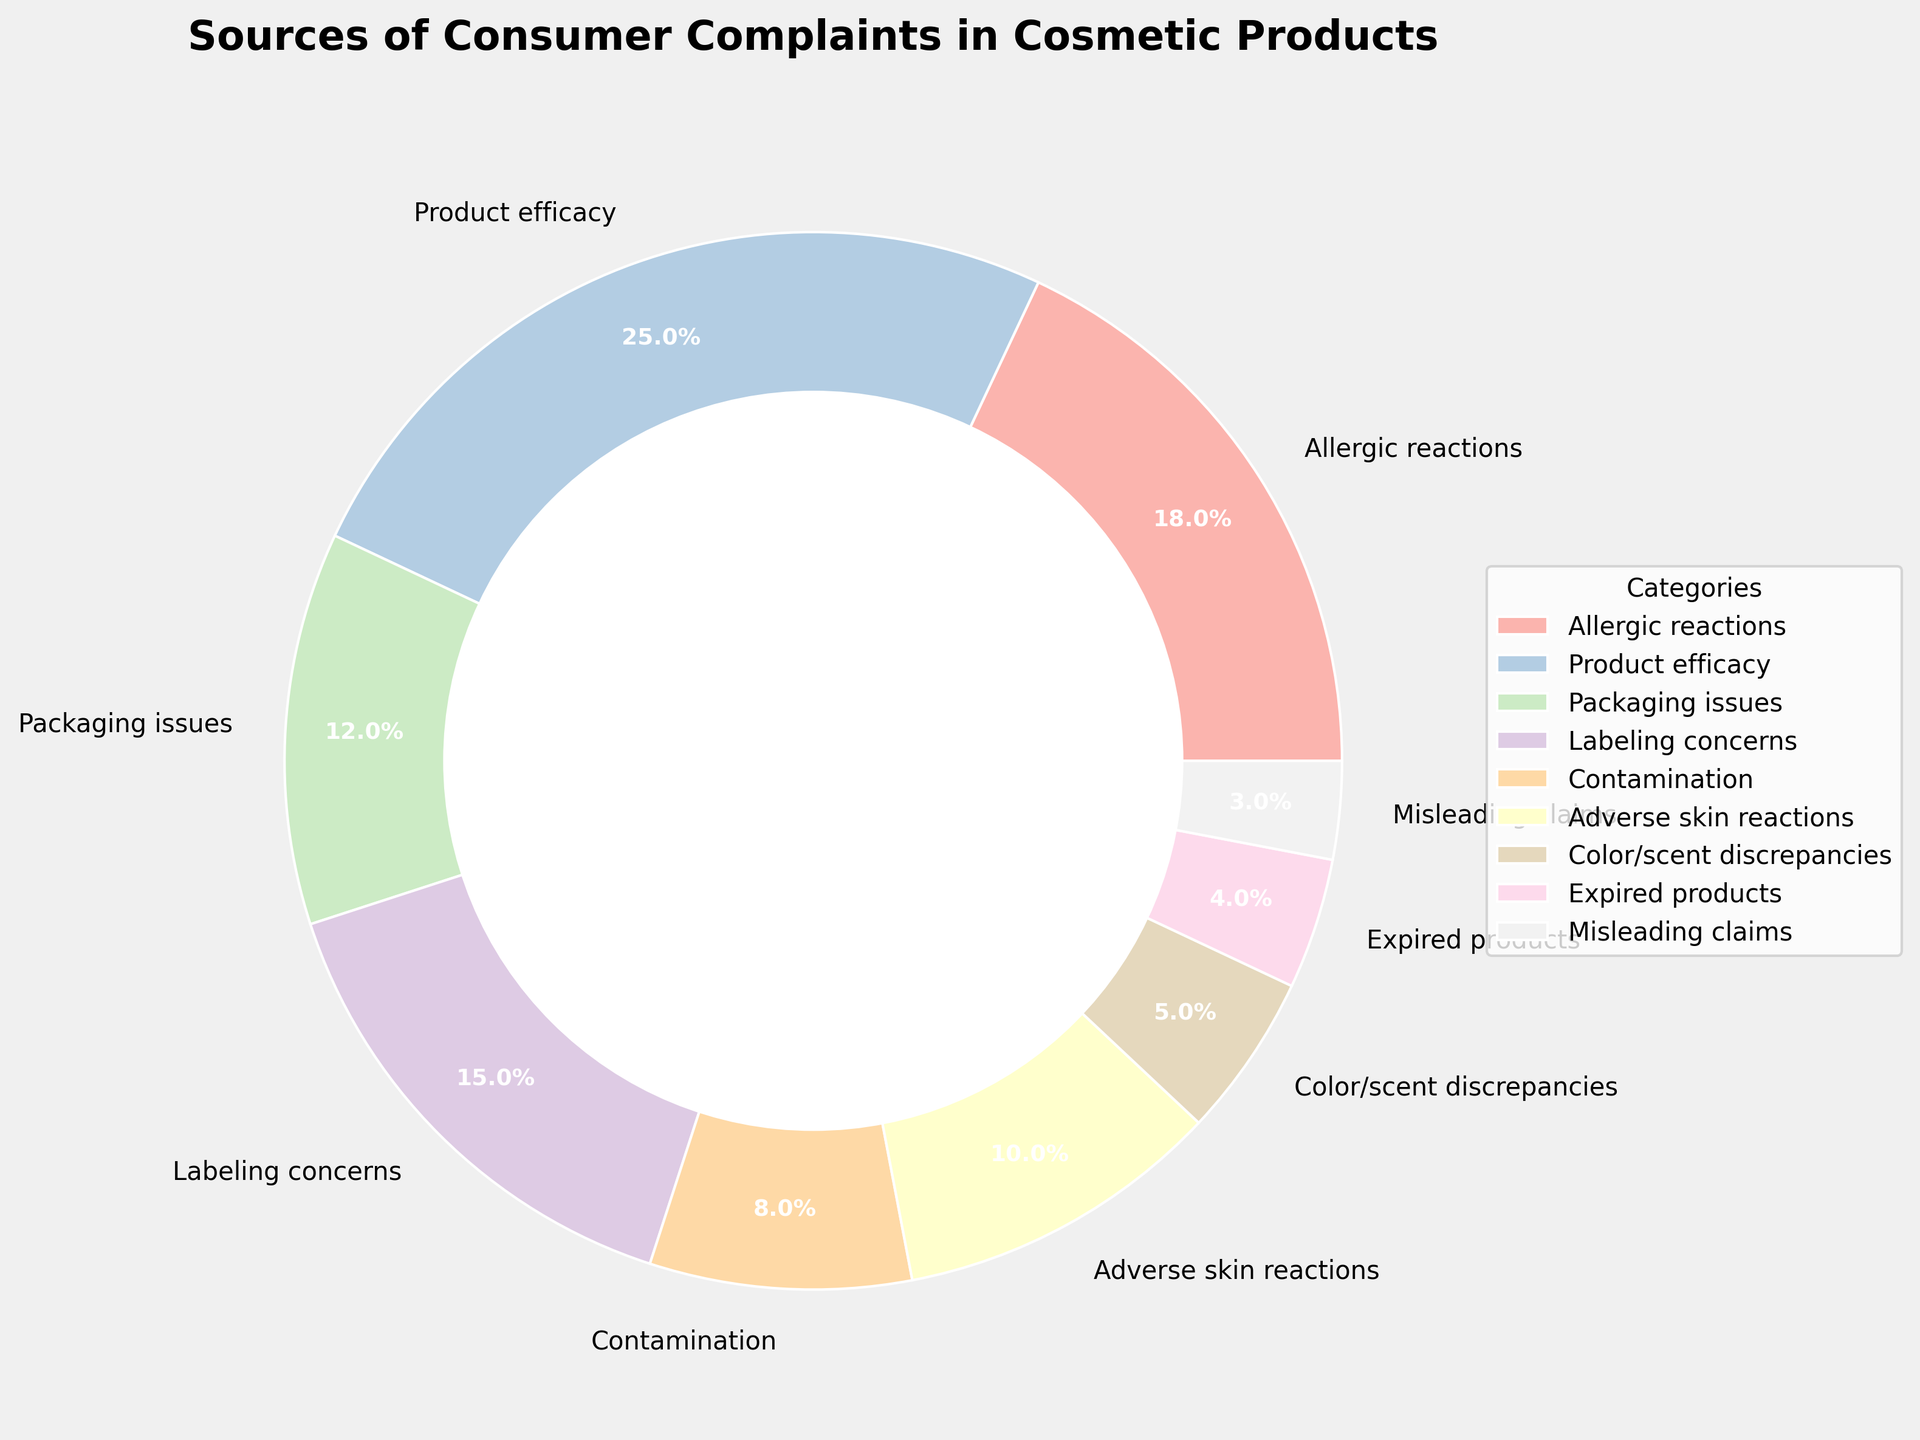What percentage of complaints are related to allergic reactions? The pie chart shows that 18% of consumer complaints are related to allergic reactions.
Answer: 18% Which category has the highest percentage of consumer complaints? By looking at the pie chart, the "Product efficacy" category has the highest percentage of complaints, which is 25%.
Answer: Product efficacy How much more frequent are complaints about labeling concerns compared to contamination? Complaints about labeling concerns constitute 15% while contamination accounts for 8%. The difference is 15% - 8% = 7%.
Answer: 7% What is the combined percentage of complaints related to adverse skin reactions and color/scent discrepancies? The pie chart shows that adverse skin reactions make up 10% and color/scent discrepancies make up 5%. The combined percentage is 10% + 5% = 15%.
Answer: 15% By what percentage do complaints about product efficacy exceed those related to expired products? Product efficacy complaints account for 25%, whereas expired products make up 4%. The percentage difference is 25% - 4% = 21%.
Answer: 21% Do complaints about packaging issues or adverse skin reactions have a higher percentage? According to the pie chart, packaging issues have 12%, while adverse skin reactions have 10%. Thus, packaging issues have a higher percentage.
Answer: Packaging issues In terms of complaint percentages, what is the ratio of misled claims to adverse skin reactions? Misleading claims account for 3%, and adverse skin reactions make up 10%. The ratio is therefore 3:10.
Answer: 3:10 